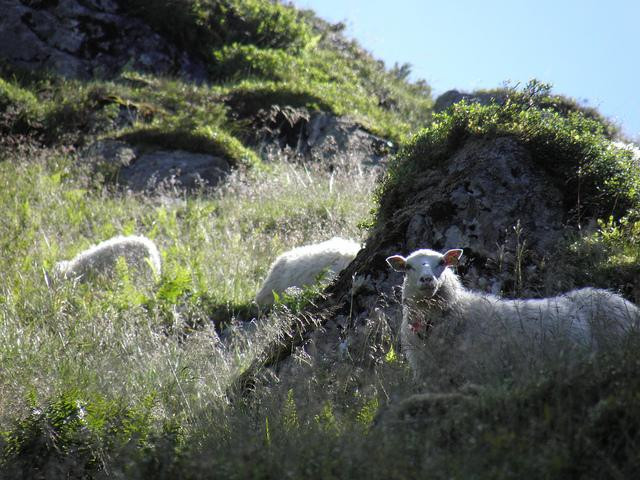What part of the animal on the right is visible? Please explain your reasoning. ears. Of the body parts visible on the animal in question, only answer a is currently visible. 